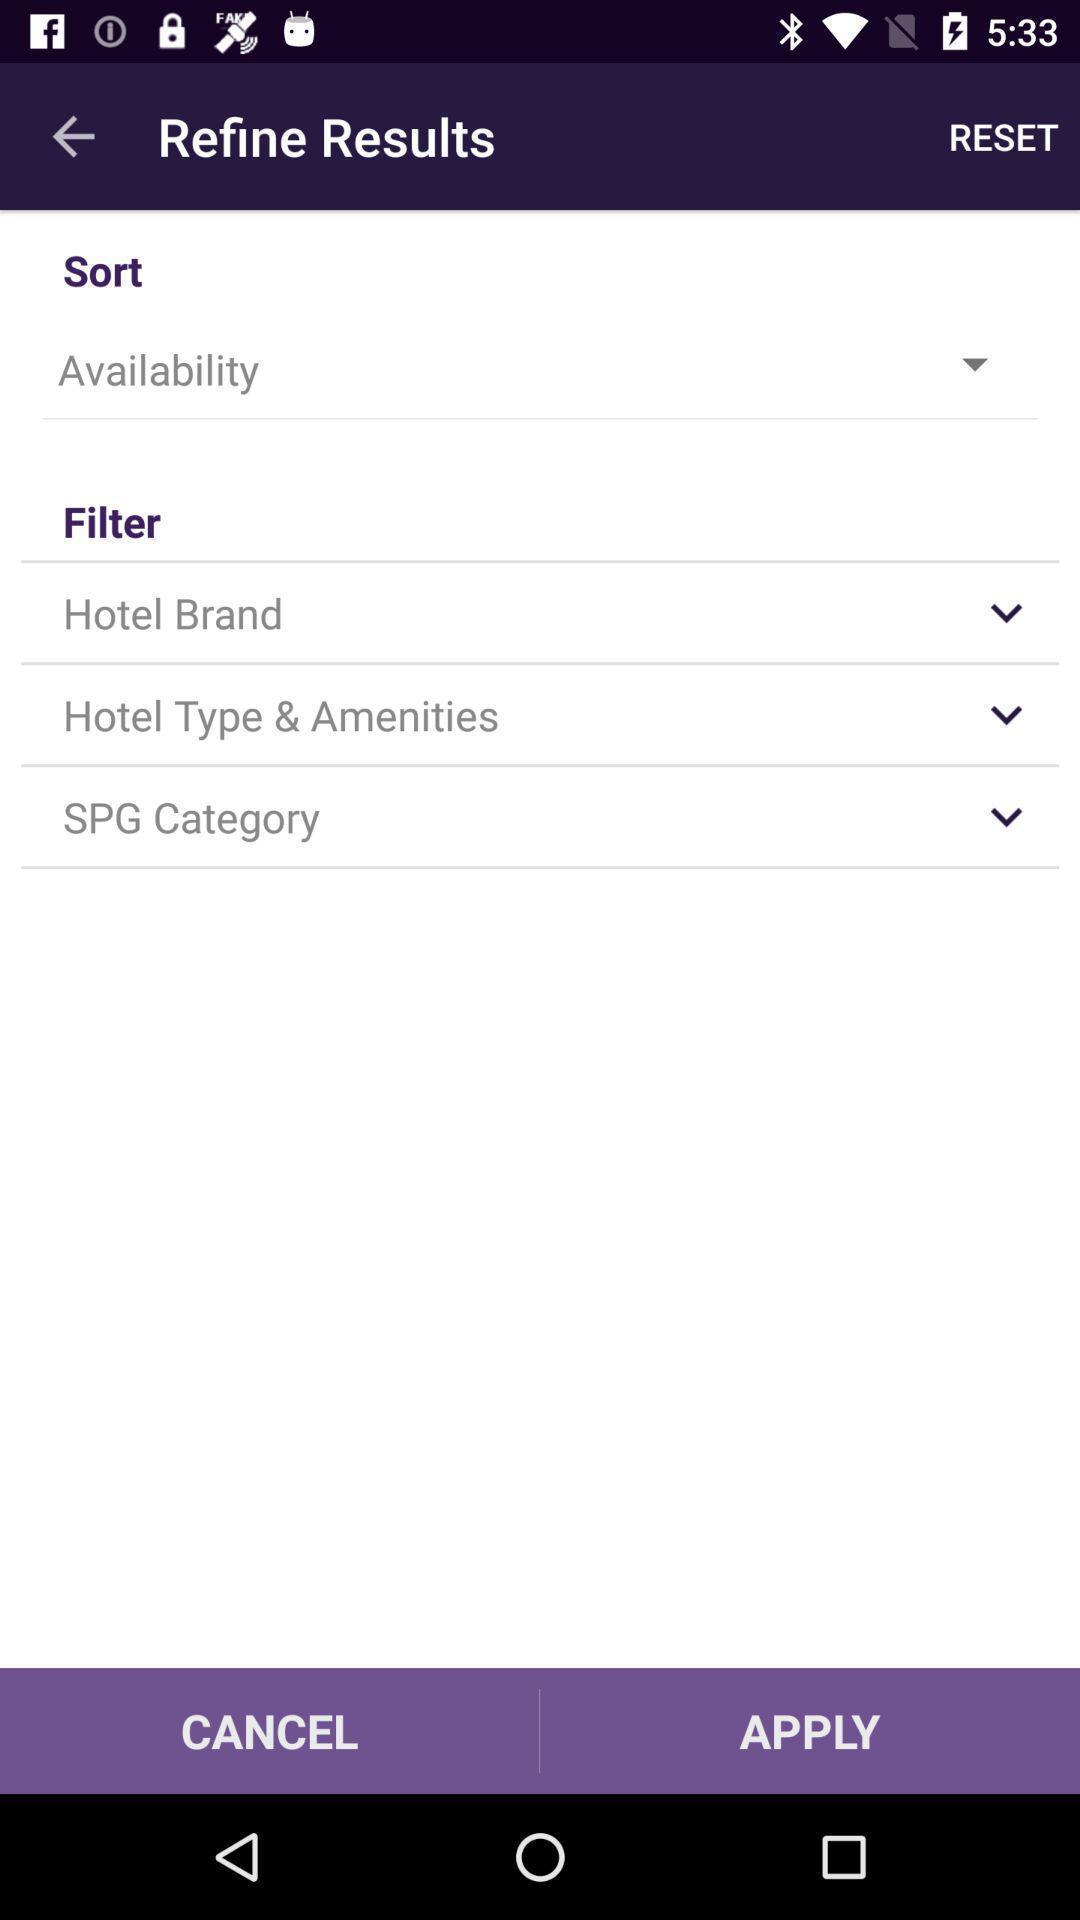Provide a description of this screenshot. Page showing sort and filter options. 